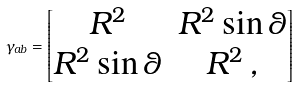<formula> <loc_0><loc_0><loc_500><loc_500>\gamma _ { a b } = \begin{bmatrix} R ^ { 2 } & R ^ { 2 } \sin \theta \\ R ^ { 2 } \sin \theta & R ^ { 2 } \, , \end{bmatrix}</formula> 